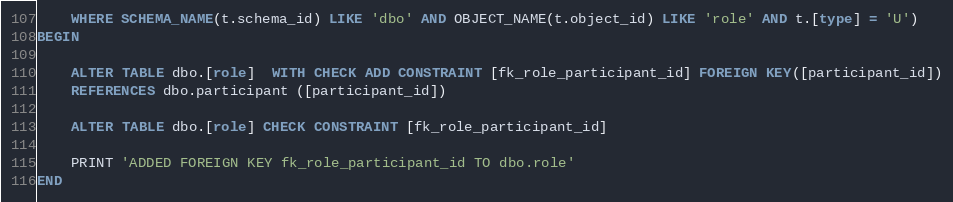<code> <loc_0><loc_0><loc_500><loc_500><_SQL_>	WHERE SCHEMA_NAME(t.schema_id) LIKE 'dbo' AND OBJECT_NAME(t.object_id) LIKE 'role' AND t.[type] = 'U')
BEGIN

	ALTER TABLE dbo.[role]  WITH CHECK ADD CONSTRAINT [fk_role_participant_id] FOREIGN KEY([participant_id])
	REFERENCES dbo.participant ([participant_id])

	ALTER TABLE dbo.[role] CHECK CONSTRAINT [fk_role_participant_id]

	PRINT 'ADDED FOREIGN KEY fk_role_participant_id TO dbo.role'
END</code> 